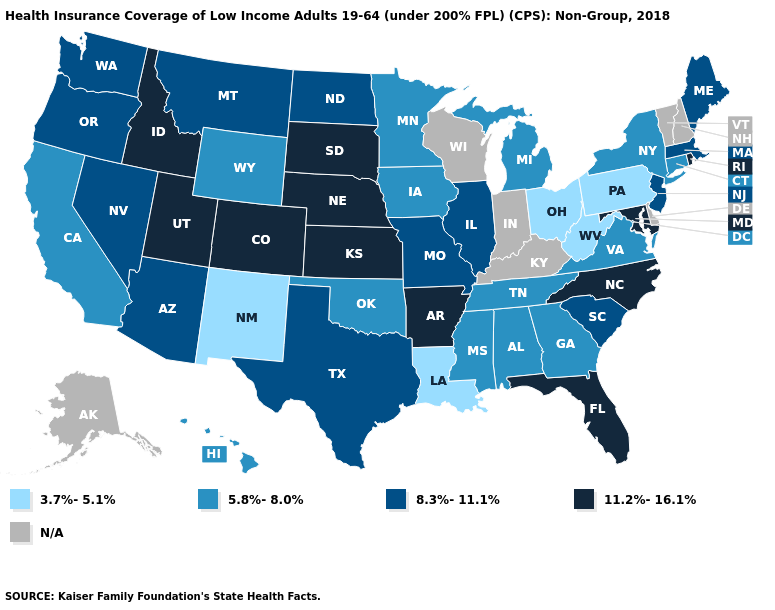What is the lowest value in the USA?
Concise answer only. 3.7%-5.1%. What is the highest value in the MidWest ?
Quick response, please. 11.2%-16.1%. Does the first symbol in the legend represent the smallest category?
Give a very brief answer. Yes. How many symbols are there in the legend?
Answer briefly. 5. Name the states that have a value in the range 11.2%-16.1%?
Give a very brief answer. Arkansas, Colorado, Florida, Idaho, Kansas, Maryland, Nebraska, North Carolina, Rhode Island, South Dakota, Utah. Name the states that have a value in the range 8.3%-11.1%?
Short answer required. Arizona, Illinois, Maine, Massachusetts, Missouri, Montana, Nevada, New Jersey, North Dakota, Oregon, South Carolina, Texas, Washington. Which states have the lowest value in the USA?
Concise answer only. Louisiana, New Mexico, Ohio, Pennsylvania, West Virginia. Does the first symbol in the legend represent the smallest category?
Keep it brief. Yes. Name the states that have a value in the range 3.7%-5.1%?
Short answer required. Louisiana, New Mexico, Ohio, Pennsylvania, West Virginia. Which states have the highest value in the USA?
Quick response, please. Arkansas, Colorado, Florida, Idaho, Kansas, Maryland, Nebraska, North Carolina, Rhode Island, South Dakota, Utah. Which states have the highest value in the USA?
Quick response, please. Arkansas, Colorado, Florida, Idaho, Kansas, Maryland, Nebraska, North Carolina, Rhode Island, South Dakota, Utah. Name the states that have a value in the range N/A?
Answer briefly. Alaska, Delaware, Indiana, Kentucky, New Hampshire, Vermont, Wisconsin. What is the value of Rhode Island?
Answer briefly. 11.2%-16.1%. 